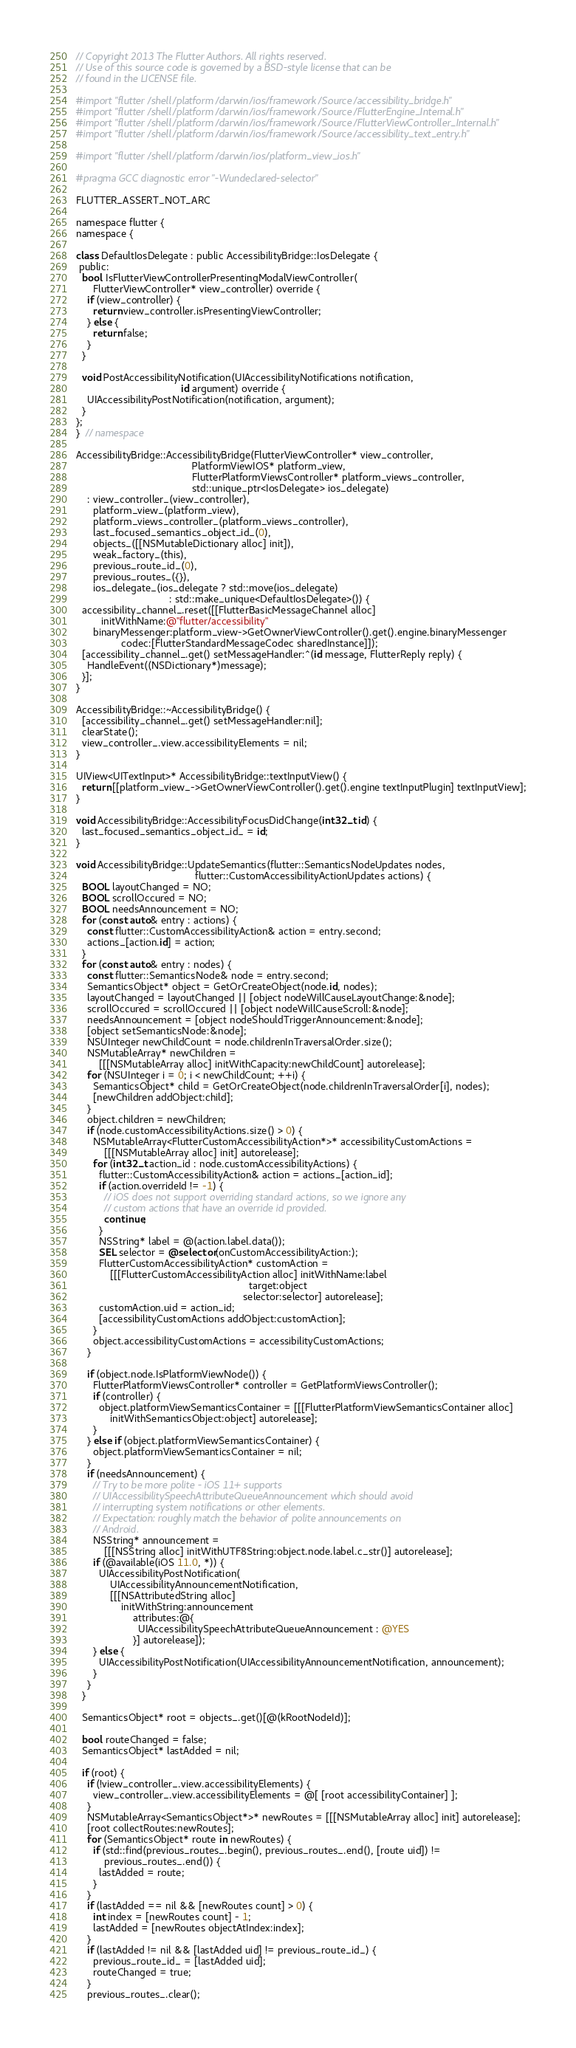Convert code to text. <code><loc_0><loc_0><loc_500><loc_500><_ObjectiveC_>// Copyright 2013 The Flutter Authors. All rights reserved.
// Use of this source code is governed by a BSD-style license that can be
// found in the LICENSE file.

#import "flutter/shell/platform/darwin/ios/framework/Source/accessibility_bridge.h"
#import "flutter/shell/platform/darwin/ios/framework/Source/FlutterEngine_Internal.h"
#import "flutter/shell/platform/darwin/ios/framework/Source/FlutterViewController_Internal.h"
#import "flutter/shell/platform/darwin/ios/framework/Source/accessibility_text_entry.h"

#import "flutter/shell/platform/darwin/ios/platform_view_ios.h"

#pragma GCC diagnostic error "-Wundeclared-selector"

FLUTTER_ASSERT_NOT_ARC

namespace flutter {
namespace {

class DefaultIosDelegate : public AccessibilityBridge::IosDelegate {
 public:
  bool IsFlutterViewControllerPresentingModalViewController(
      FlutterViewController* view_controller) override {
    if (view_controller) {
      return view_controller.isPresentingViewController;
    } else {
      return false;
    }
  }

  void PostAccessibilityNotification(UIAccessibilityNotifications notification,
                                     id argument) override {
    UIAccessibilityPostNotification(notification, argument);
  }
};
}  // namespace

AccessibilityBridge::AccessibilityBridge(FlutterViewController* view_controller,
                                         PlatformViewIOS* platform_view,
                                         FlutterPlatformViewsController* platform_views_controller,
                                         std::unique_ptr<IosDelegate> ios_delegate)
    : view_controller_(view_controller),
      platform_view_(platform_view),
      platform_views_controller_(platform_views_controller),
      last_focused_semantics_object_id_(0),
      objects_([[NSMutableDictionary alloc] init]),
      weak_factory_(this),
      previous_route_id_(0),
      previous_routes_({}),
      ios_delegate_(ios_delegate ? std::move(ios_delegate)
                                 : std::make_unique<DefaultIosDelegate>()) {
  accessibility_channel_.reset([[FlutterBasicMessageChannel alloc]
         initWithName:@"flutter/accessibility"
      binaryMessenger:platform_view->GetOwnerViewController().get().engine.binaryMessenger
                codec:[FlutterStandardMessageCodec sharedInstance]]);
  [accessibility_channel_.get() setMessageHandler:^(id message, FlutterReply reply) {
    HandleEvent((NSDictionary*)message);
  }];
}

AccessibilityBridge::~AccessibilityBridge() {
  [accessibility_channel_.get() setMessageHandler:nil];
  clearState();
  view_controller_.view.accessibilityElements = nil;
}

UIView<UITextInput>* AccessibilityBridge::textInputView() {
  return [[platform_view_->GetOwnerViewController().get().engine textInputPlugin] textInputView];
}

void AccessibilityBridge::AccessibilityFocusDidChange(int32_t id) {
  last_focused_semantics_object_id_ = id;
}

void AccessibilityBridge::UpdateSemantics(flutter::SemanticsNodeUpdates nodes,
                                          flutter::CustomAccessibilityActionUpdates actions) {
  BOOL layoutChanged = NO;
  BOOL scrollOccured = NO;
  BOOL needsAnnouncement = NO;
  for (const auto& entry : actions) {
    const flutter::CustomAccessibilityAction& action = entry.second;
    actions_[action.id] = action;
  }
  for (const auto& entry : nodes) {
    const flutter::SemanticsNode& node = entry.second;
    SemanticsObject* object = GetOrCreateObject(node.id, nodes);
    layoutChanged = layoutChanged || [object nodeWillCauseLayoutChange:&node];
    scrollOccured = scrollOccured || [object nodeWillCauseScroll:&node];
    needsAnnouncement = [object nodeShouldTriggerAnnouncement:&node];
    [object setSemanticsNode:&node];
    NSUInteger newChildCount = node.childrenInTraversalOrder.size();
    NSMutableArray* newChildren =
        [[[NSMutableArray alloc] initWithCapacity:newChildCount] autorelease];
    for (NSUInteger i = 0; i < newChildCount; ++i) {
      SemanticsObject* child = GetOrCreateObject(node.childrenInTraversalOrder[i], nodes);
      [newChildren addObject:child];
    }
    object.children = newChildren;
    if (node.customAccessibilityActions.size() > 0) {
      NSMutableArray<FlutterCustomAccessibilityAction*>* accessibilityCustomActions =
          [[[NSMutableArray alloc] init] autorelease];
      for (int32_t action_id : node.customAccessibilityActions) {
        flutter::CustomAccessibilityAction& action = actions_[action_id];
        if (action.overrideId != -1) {
          // iOS does not support overriding standard actions, so we ignore any
          // custom actions that have an override id provided.
          continue;
        }
        NSString* label = @(action.label.data());
        SEL selector = @selector(onCustomAccessibilityAction:);
        FlutterCustomAccessibilityAction* customAction =
            [[[FlutterCustomAccessibilityAction alloc] initWithName:label
                                                             target:object
                                                           selector:selector] autorelease];
        customAction.uid = action_id;
        [accessibilityCustomActions addObject:customAction];
      }
      object.accessibilityCustomActions = accessibilityCustomActions;
    }

    if (object.node.IsPlatformViewNode()) {
      FlutterPlatformViewsController* controller = GetPlatformViewsController();
      if (controller) {
        object.platformViewSemanticsContainer = [[[FlutterPlatformViewSemanticsContainer alloc]
            initWithSemanticsObject:object] autorelease];
      }
    } else if (object.platformViewSemanticsContainer) {
      object.platformViewSemanticsContainer = nil;
    }
    if (needsAnnouncement) {
      // Try to be more polite - iOS 11+ supports
      // UIAccessibilitySpeechAttributeQueueAnnouncement which should avoid
      // interrupting system notifications or other elements.
      // Expectation: roughly match the behavior of polite announcements on
      // Android.
      NSString* announcement =
          [[[NSString alloc] initWithUTF8String:object.node.label.c_str()] autorelease];
      if (@available(iOS 11.0, *)) {
        UIAccessibilityPostNotification(
            UIAccessibilityAnnouncementNotification,
            [[[NSAttributedString alloc]
                initWithString:announcement
                    attributes:@{
                      UIAccessibilitySpeechAttributeQueueAnnouncement : @YES
                    }] autorelease]);
      } else {
        UIAccessibilityPostNotification(UIAccessibilityAnnouncementNotification, announcement);
      }
    }
  }

  SemanticsObject* root = objects_.get()[@(kRootNodeId)];

  bool routeChanged = false;
  SemanticsObject* lastAdded = nil;

  if (root) {
    if (!view_controller_.view.accessibilityElements) {
      view_controller_.view.accessibilityElements = @[ [root accessibilityContainer] ];
    }
    NSMutableArray<SemanticsObject*>* newRoutes = [[[NSMutableArray alloc] init] autorelease];
    [root collectRoutes:newRoutes];
    for (SemanticsObject* route in newRoutes) {
      if (std::find(previous_routes_.begin(), previous_routes_.end(), [route uid]) !=
          previous_routes_.end()) {
        lastAdded = route;
      }
    }
    if (lastAdded == nil && [newRoutes count] > 0) {
      int index = [newRoutes count] - 1;
      lastAdded = [newRoutes objectAtIndex:index];
    }
    if (lastAdded != nil && [lastAdded uid] != previous_route_id_) {
      previous_route_id_ = [lastAdded uid];
      routeChanged = true;
    }
    previous_routes_.clear();</code> 